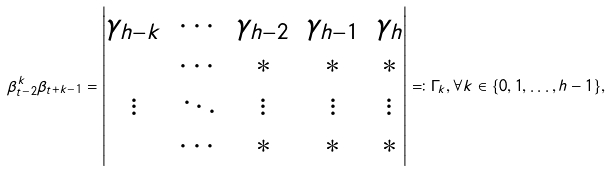Convert formula to latex. <formula><loc_0><loc_0><loc_500><loc_500>\beta _ { t - 2 } ^ { k } \beta _ { t + k - 1 } = \begin{vmatrix} \gamma _ { h - k } & \cdots & \gamma _ { h - 2 } & \gamma _ { h - 1 } & \gamma _ { h } \\ & \cdots & * & * & * \\ \vdots & \ddots & \vdots & \vdots & \vdots \\ & \cdots & * & * & * \end{vmatrix} \eqqcolon \Gamma _ { k } , \forall k \in \{ 0 , 1 , \dots , h - 1 \} ,</formula> 